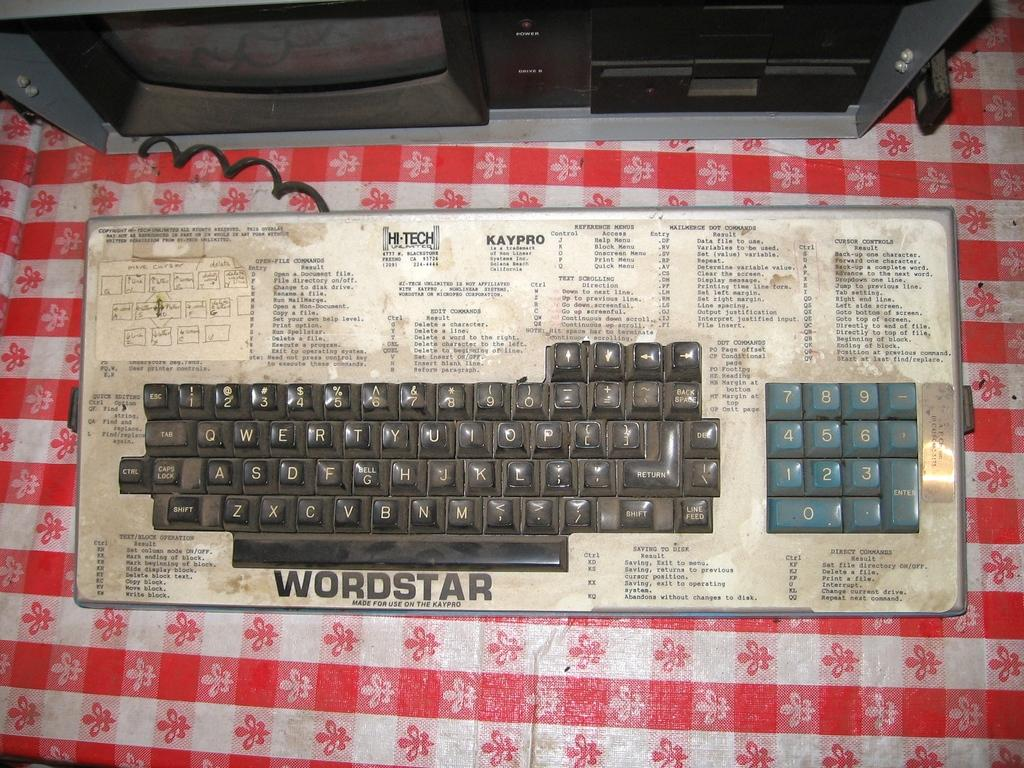<image>
Share a concise interpretation of the image provided. A Wordstar computer keyboard is shown sitting on a table. 